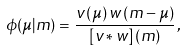Convert formula to latex. <formula><loc_0><loc_0><loc_500><loc_500>\phi ( \mu | m ) = \frac { v \left ( \mu \right ) w \left ( m - \mu \right ) } { \left [ v * w \right ] \left ( m \right ) } \, ,</formula> 